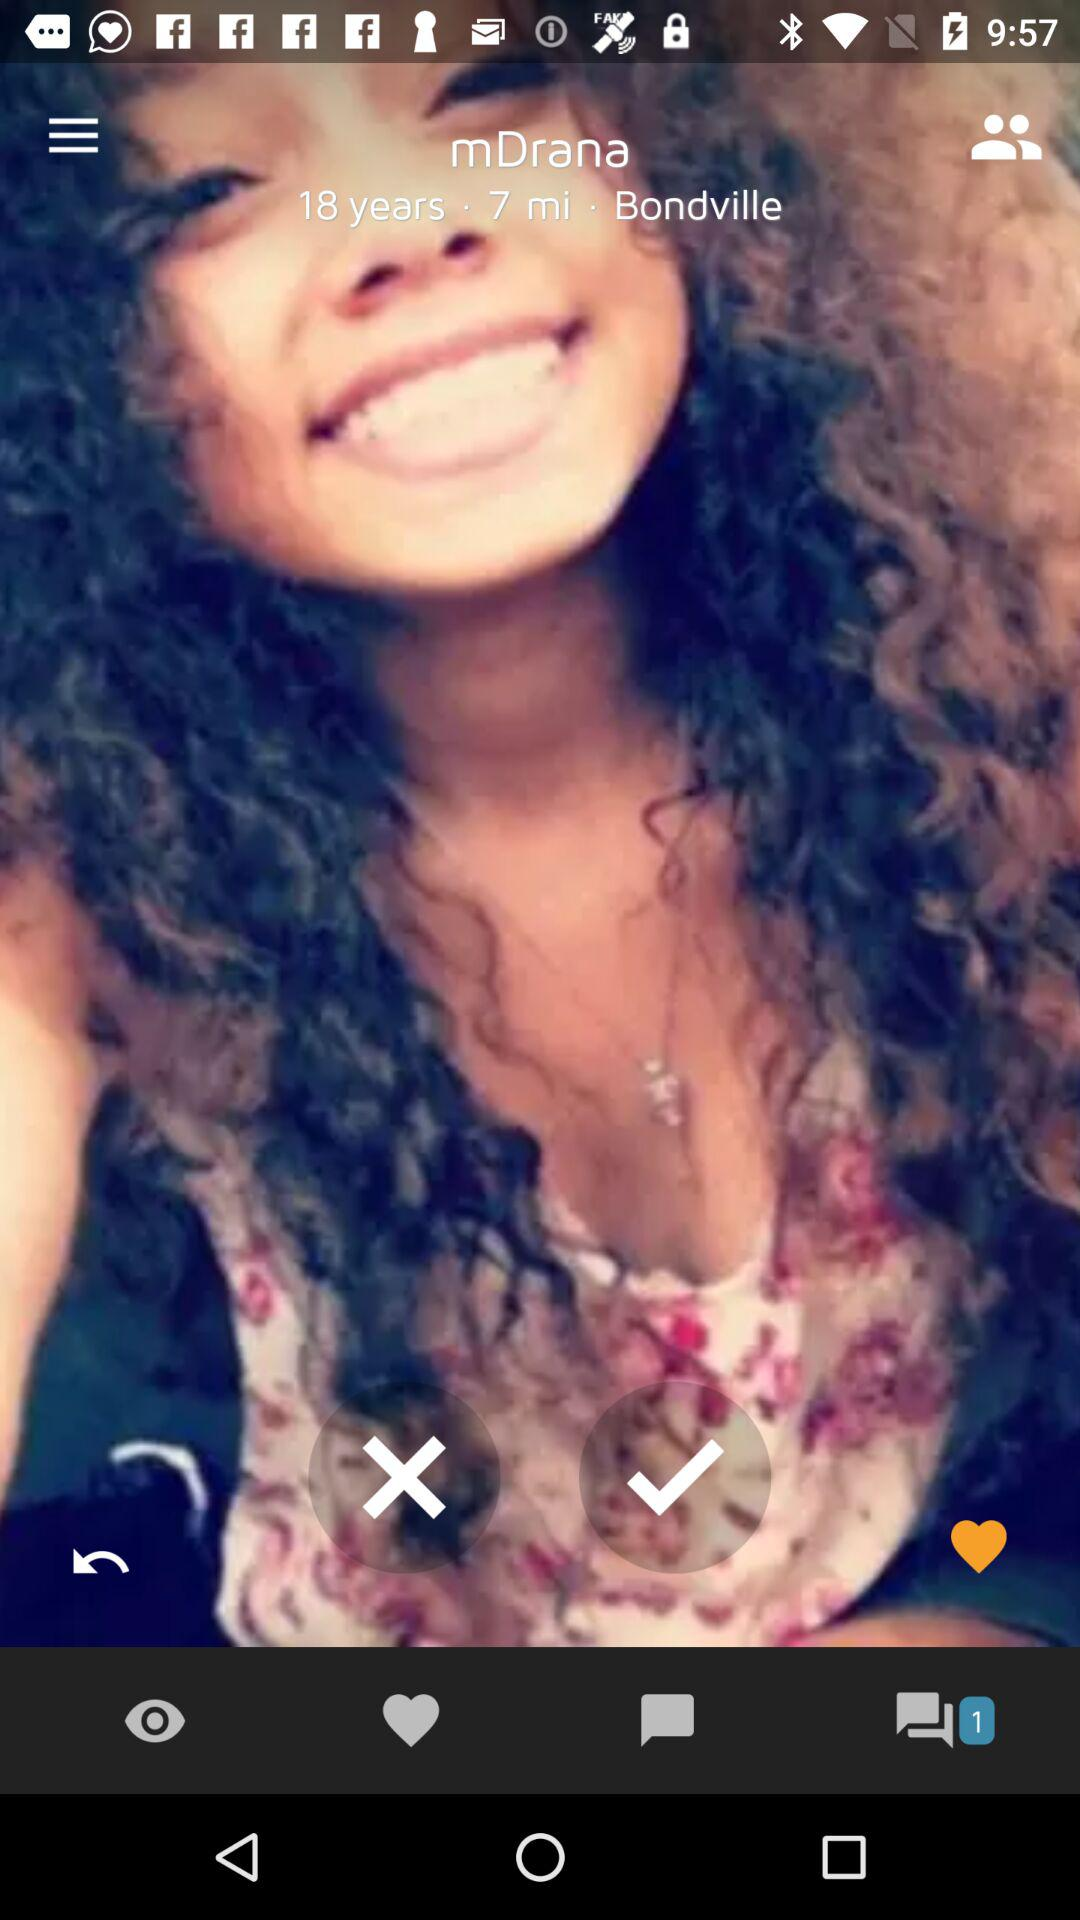What is the age of "mDrana"? The age is 18 years. 